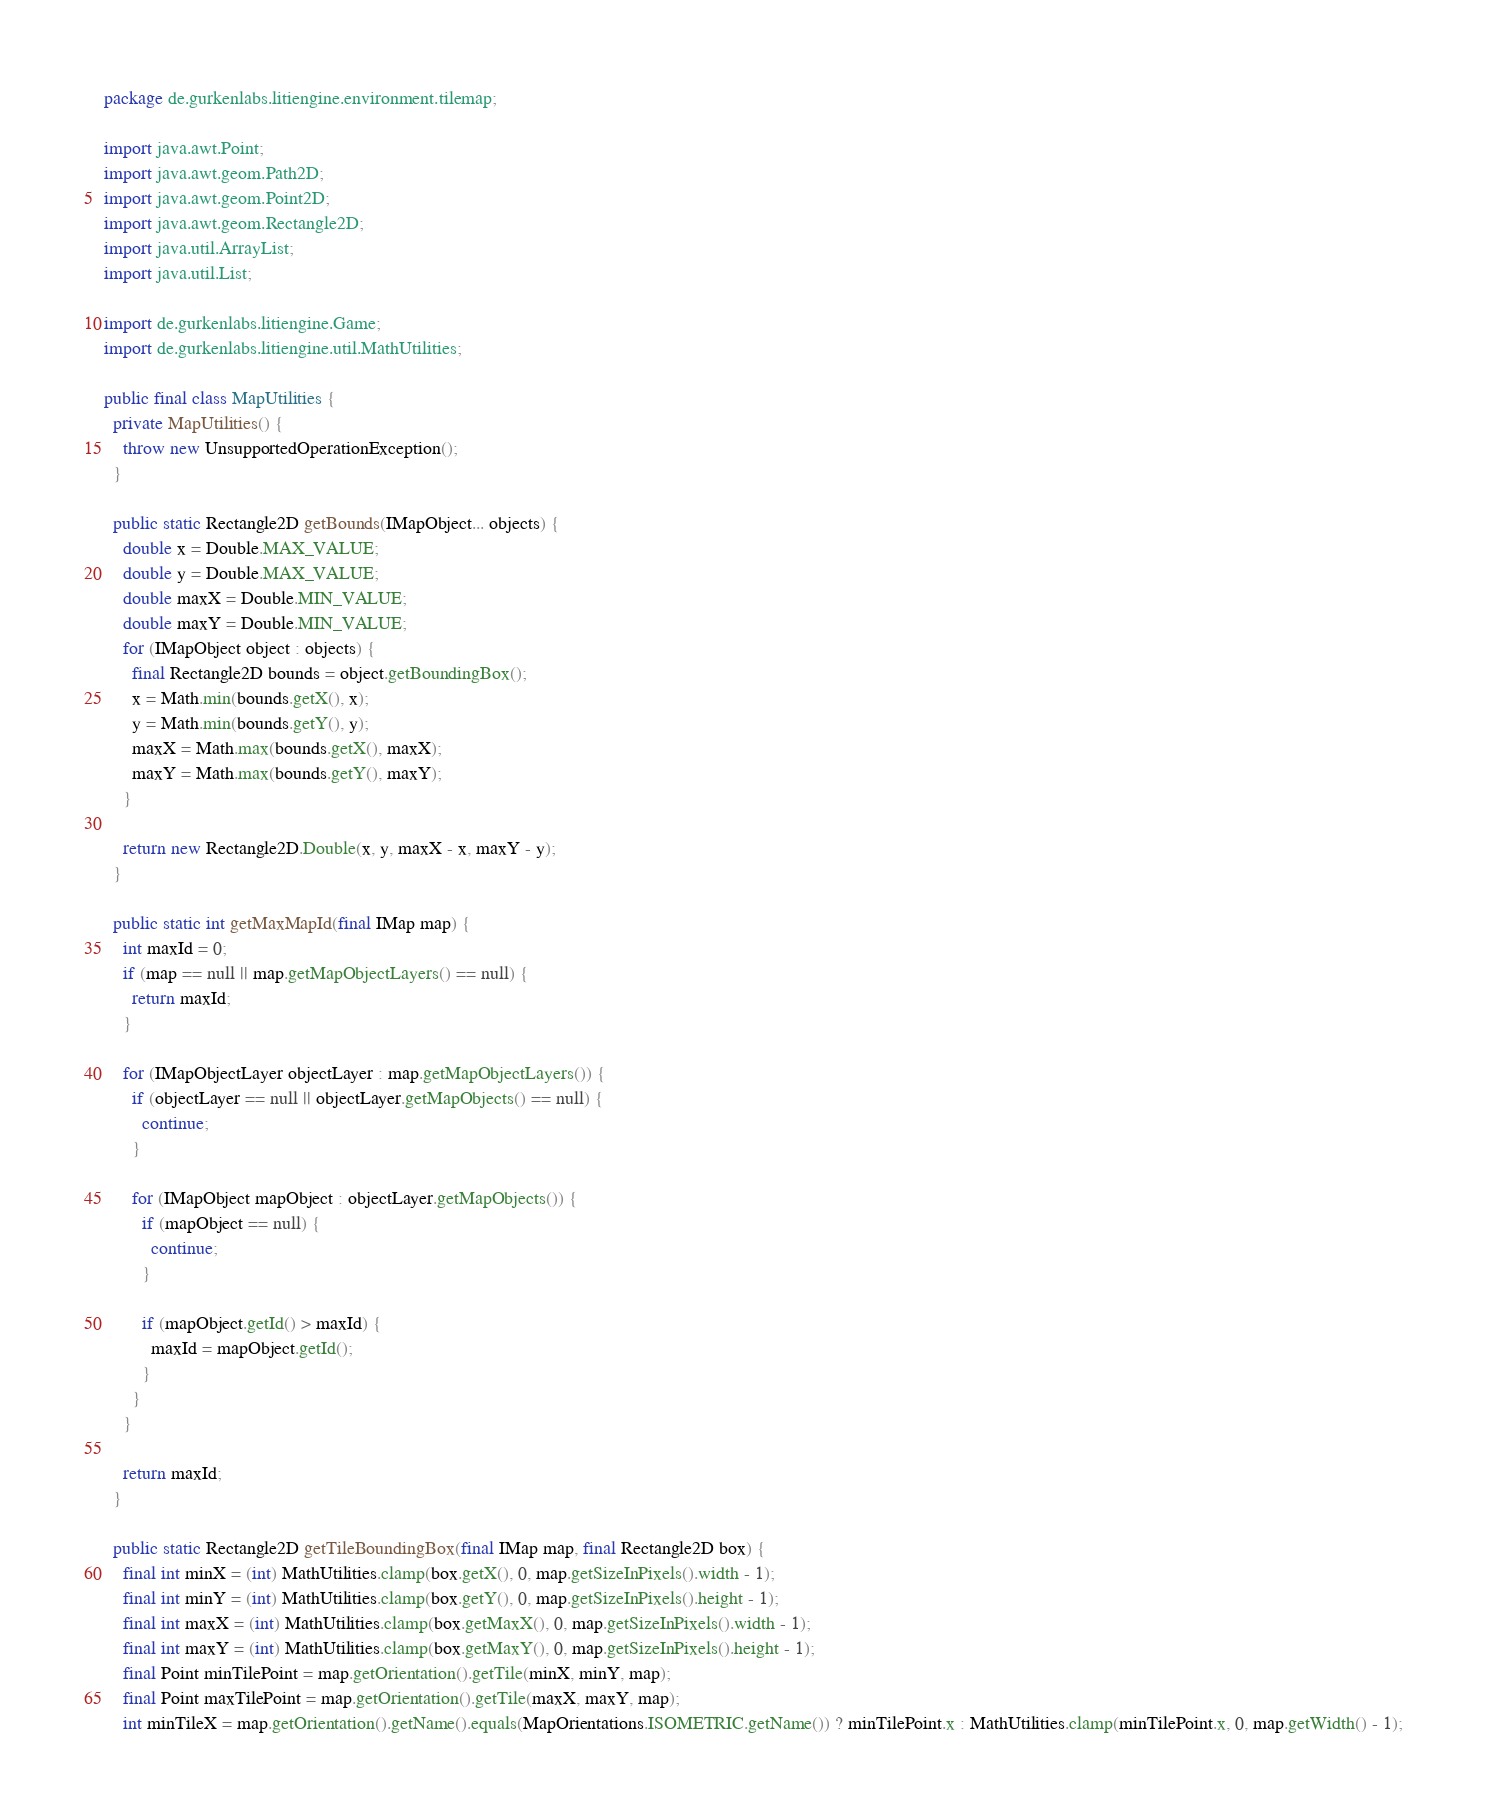<code> <loc_0><loc_0><loc_500><loc_500><_Java_>package de.gurkenlabs.litiengine.environment.tilemap;

import java.awt.Point;
import java.awt.geom.Path2D;
import java.awt.geom.Point2D;
import java.awt.geom.Rectangle2D;
import java.util.ArrayList;
import java.util.List;

import de.gurkenlabs.litiengine.Game;
import de.gurkenlabs.litiengine.util.MathUtilities;

public final class MapUtilities {
  private MapUtilities() {
    throw new UnsupportedOperationException();
  }

  public static Rectangle2D getBounds(IMapObject... objects) {
    double x = Double.MAX_VALUE;
    double y = Double.MAX_VALUE;
    double maxX = Double.MIN_VALUE;
    double maxY = Double.MIN_VALUE;
    for (IMapObject object : objects) {
      final Rectangle2D bounds = object.getBoundingBox();
      x = Math.min(bounds.getX(), x);
      y = Math.min(bounds.getY(), y);
      maxX = Math.max(bounds.getX(), maxX);
      maxY = Math.max(bounds.getY(), maxY);
    }

    return new Rectangle2D.Double(x, y, maxX - x, maxY - y);
  }

  public static int getMaxMapId(final IMap map) {
    int maxId = 0;
    if (map == null || map.getMapObjectLayers() == null) {
      return maxId;
    }

    for (IMapObjectLayer objectLayer : map.getMapObjectLayers()) {
      if (objectLayer == null || objectLayer.getMapObjects() == null) {
        continue;
      }

      for (IMapObject mapObject : objectLayer.getMapObjects()) {
        if (mapObject == null) {
          continue;
        }

        if (mapObject.getId() > maxId) {
          maxId = mapObject.getId();
        }
      }
    }

    return maxId;
  }

  public static Rectangle2D getTileBoundingBox(final IMap map, final Rectangle2D box) {
    final int minX = (int) MathUtilities.clamp(box.getX(), 0, map.getSizeInPixels().width - 1);
    final int minY = (int) MathUtilities.clamp(box.getY(), 0, map.getSizeInPixels().height - 1);
    final int maxX = (int) MathUtilities.clamp(box.getMaxX(), 0, map.getSizeInPixels().width - 1);
    final int maxY = (int) MathUtilities.clamp(box.getMaxY(), 0, map.getSizeInPixels().height - 1);
    final Point minTilePoint = map.getOrientation().getTile(minX, minY, map);
    final Point maxTilePoint = map.getOrientation().getTile(maxX, maxY, map);
    int minTileX = map.getOrientation().getName().equals(MapOrientations.ISOMETRIC.getName()) ? minTilePoint.x : MathUtilities.clamp(minTilePoint.x, 0, map.getWidth() - 1);</code> 